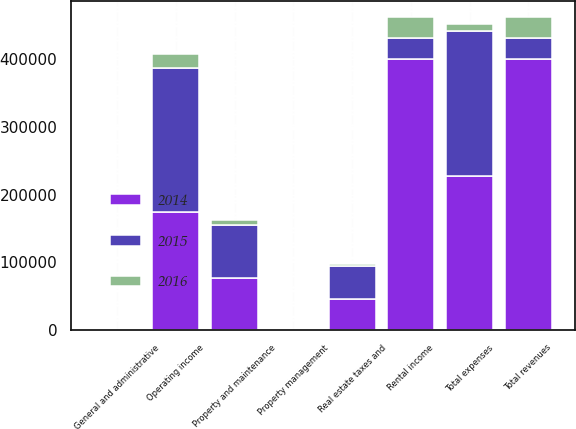Convert chart. <chart><loc_0><loc_0><loc_500><loc_500><stacked_bar_chart><ecel><fcel>Rental income<fcel>Total revenues<fcel>Property and maintenance<fcel>Real estate taxes and<fcel>Property management<fcel>General and administrative<fcel>Total expenses<fcel>Operating income<nl><fcel>2016<fcel>30785<fcel>30785<fcel>7838<fcel>2912<fcel>2<fcel>23<fcel>10775<fcel>20010<nl><fcel>2015<fcel>30785<fcel>30785<fcel>78189<fcel>48403<fcel>11<fcel>38<fcel>214257<fcel>213176<nl><fcel>2014<fcel>401134<fcel>401134<fcel>76579<fcel>46416<fcel>11<fcel>24<fcel>227134<fcel>174000<nl></chart> 